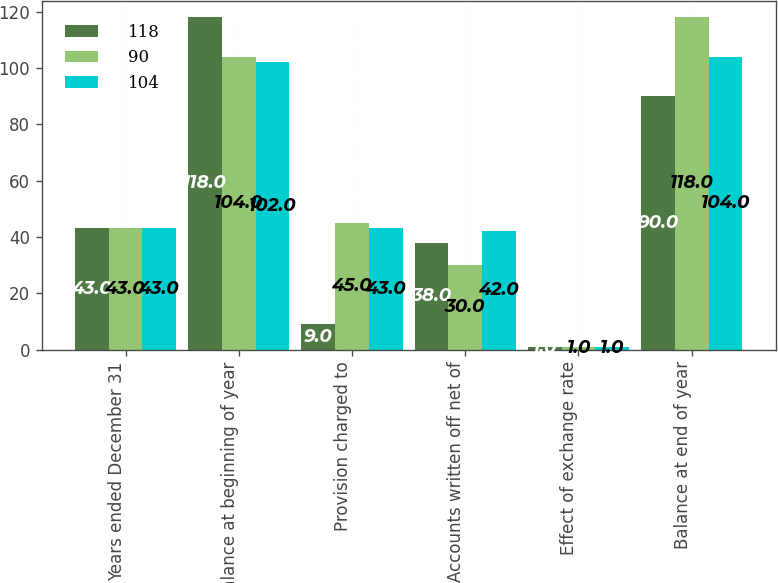<chart> <loc_0><loc_0><loc_500><loc_500><stacked_bar_chart><ecel><fcel>Years ended December 31<fcel>Balance at beginning of year<fcel>Provision charged to<fcel>Accounts written off net of<fcel>Effect of exchange rate<fcel>Balance at end of year<nl><fcel>118<fcel>43<fcel>118<fcel>9<fcel>38<fcel>1<fcel>90<nl><fcel>90<fcel>43<fcel>104<fcel>45<fcel>30<fcel>1<fcel>118<nl><fcel>104<fcel>43<fcel>102<fcel>43<fcel>42<fcel>1<fcel>104<nl></chart> 